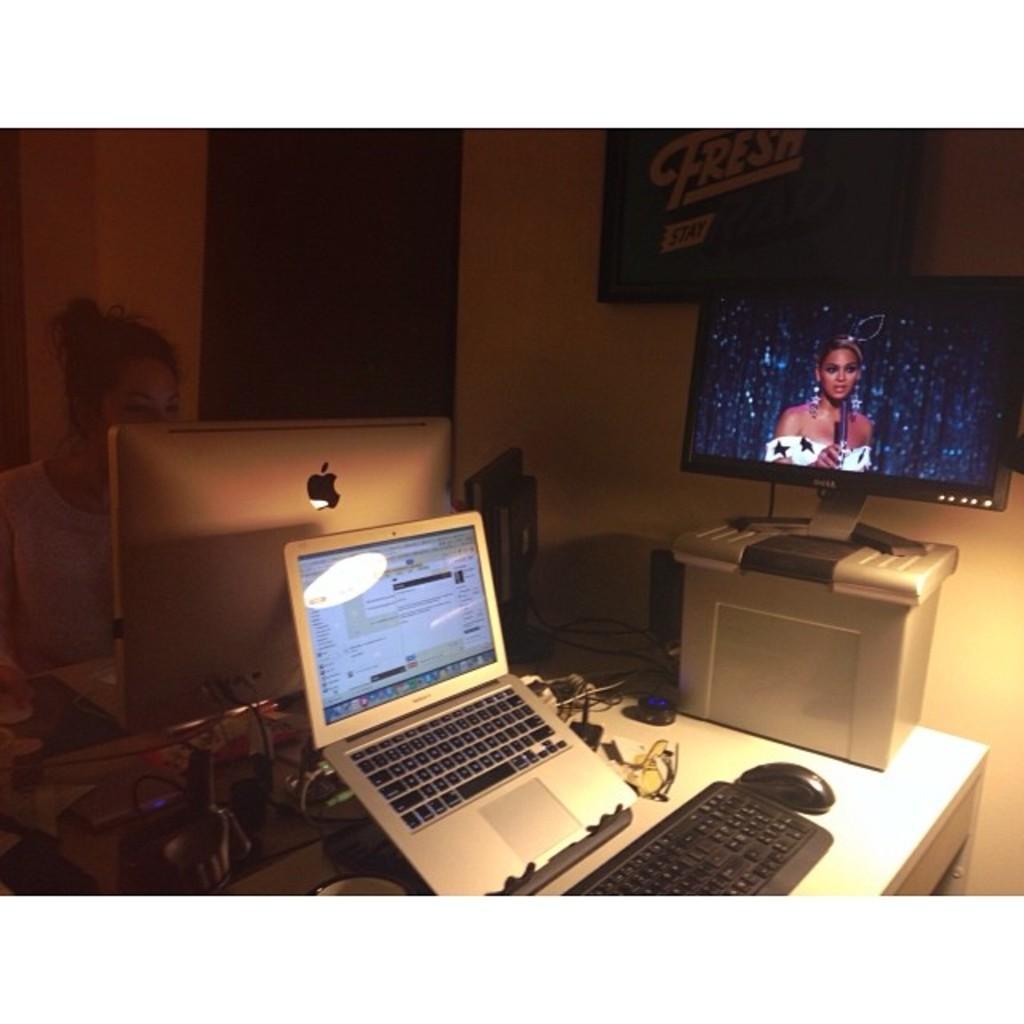Can you describe this image briefly? In this image there is a girl who is using the desktop,beside the desktop there is a laptop which is kept on the table. To the right side there is a television,under the television there is a box. At the background there is a door and a small hoarding. 